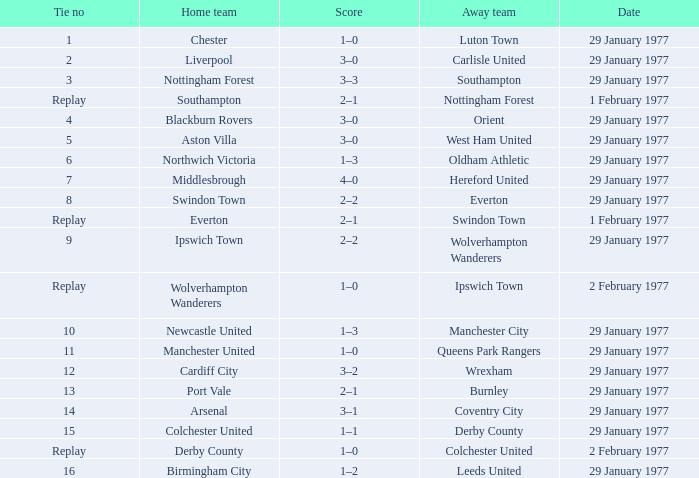What is the tie number when the home team is Port Vale? 13.0. 